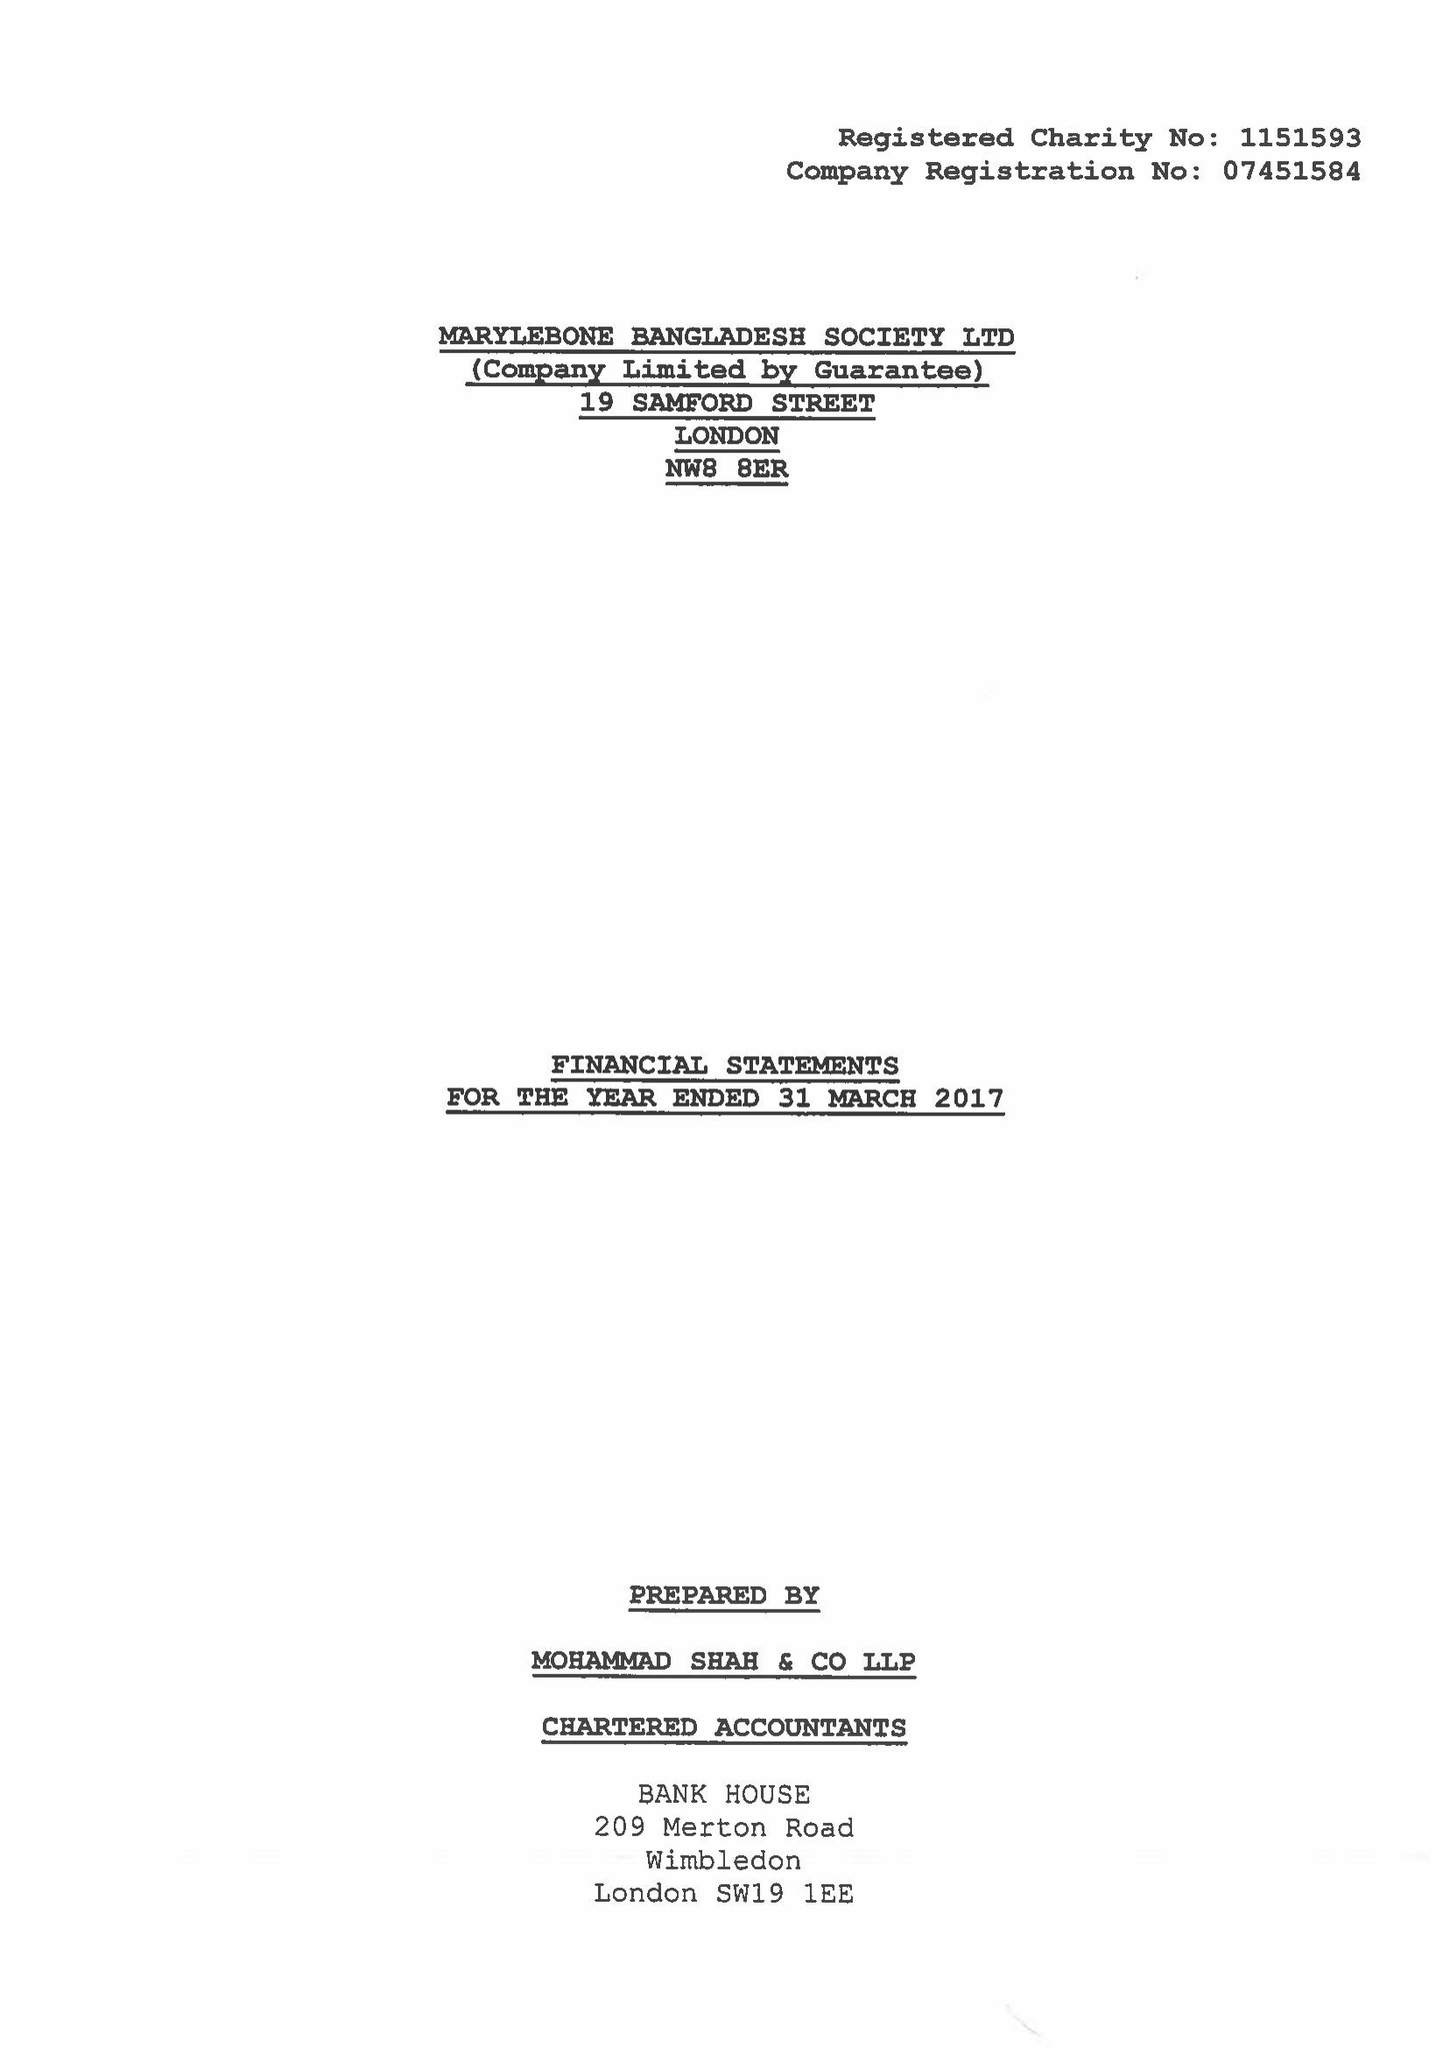What is the value for the income_annually_in_british_pounds?
Answer the question using a single word or phrase. 167534.00 